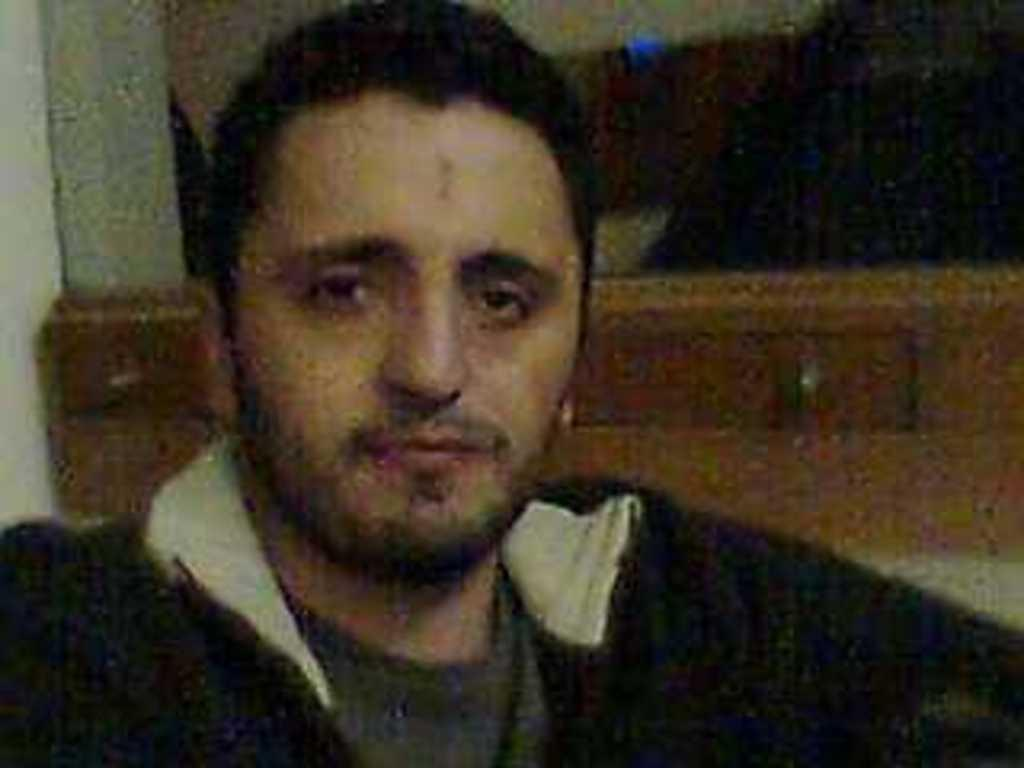What is the main subject in the foreground of the image? There is a man in the foreground of the image. Can you describe the background of the image? The background of the image is not clear. What type of quartz can be seen on the man's toe in the image? There is no quartz or any reference to a man's toe in the image. 